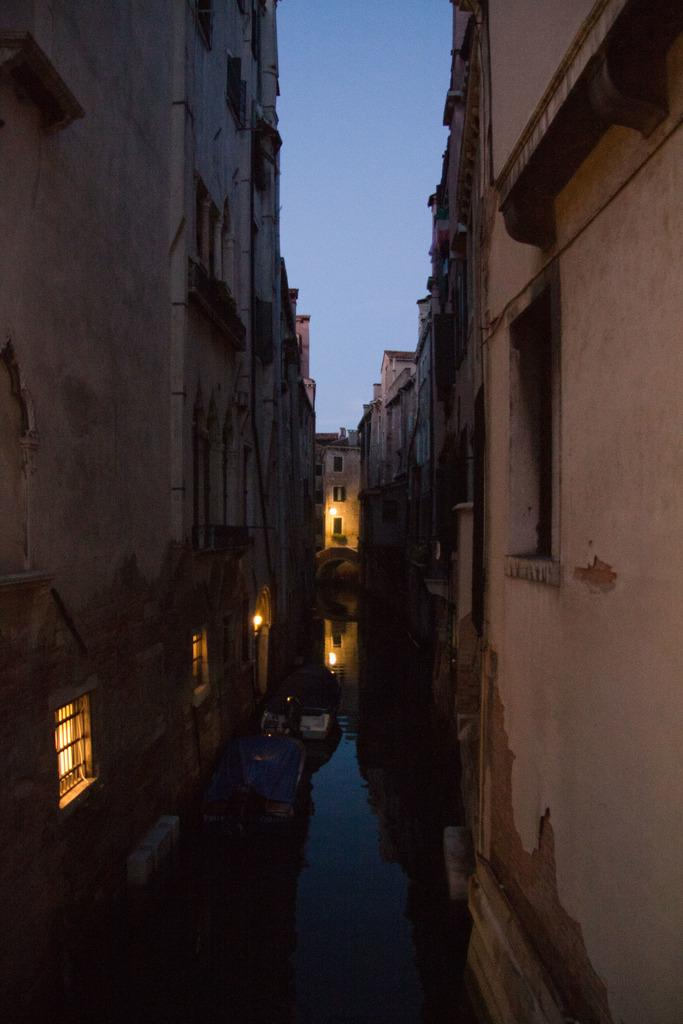What type of structures can be seen in the image? There are many buildings in the image. What type of lighting is present in the image? There are lamps visible in the image. What natural element is present at the bottom of the image? There is water at the bottom of the image. What part of the natural environment is visible at the top of the image? There is sky visible at the top of the image. What type of cloth is draped over the cemetery in the image? There is no cemetery or cloth present in the image. 